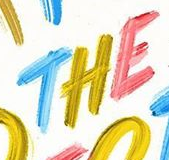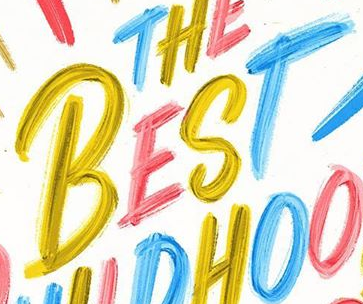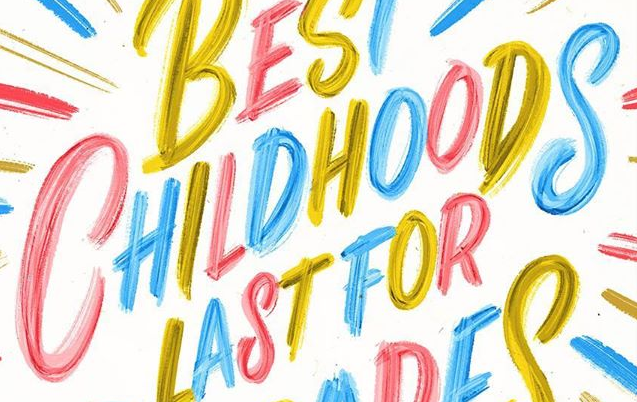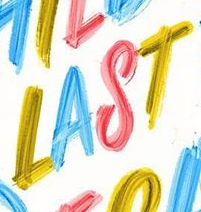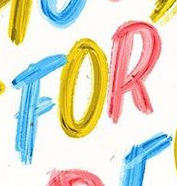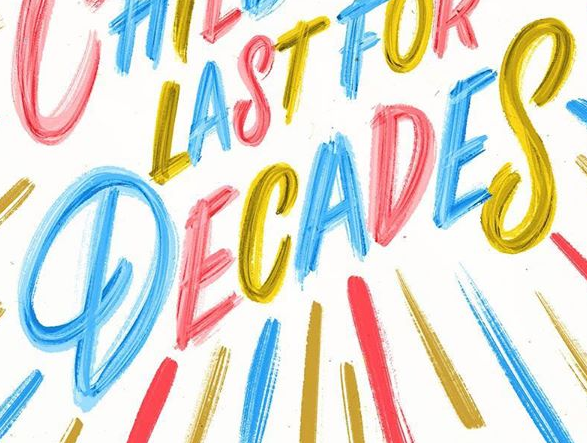Read the text from these images in sequence, separated by a semicolon. THE; BEST; CHILDHOODS; LAST; FOR; DECADES 